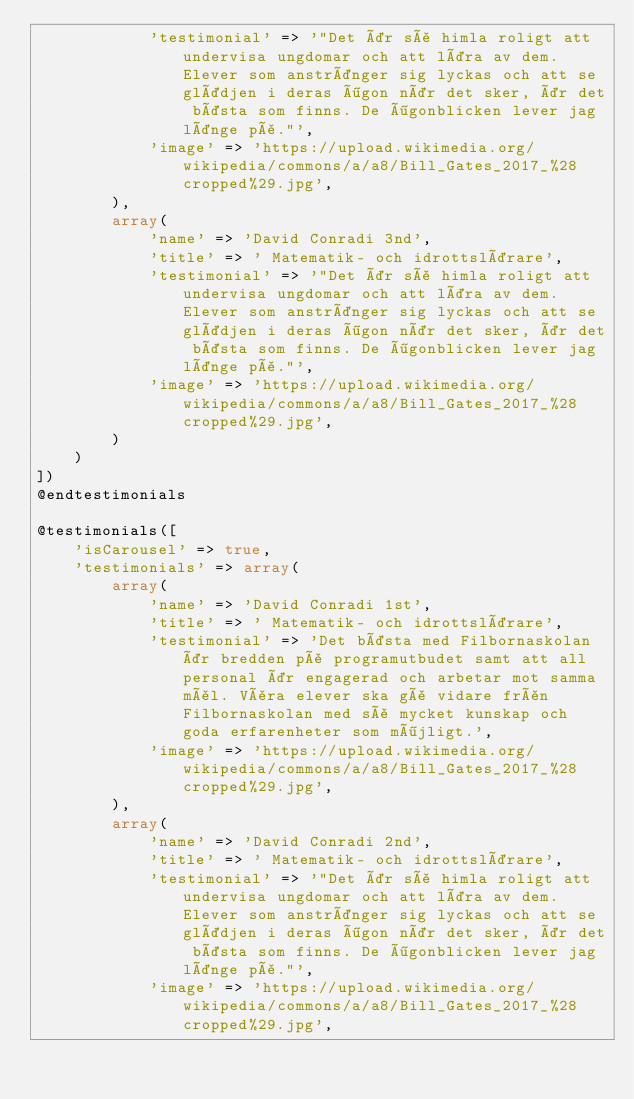Convert code to text. <code><loc_0><loc_0><loc_500><loc_500><_PHP_>            'testimonial' => '"Det är så himla roligt att undervisa ungdomar och att lära av dem. Elever som anstränger sig lyckas och att se glädjen i deras ögon när det sker, är det bästa som finns. De ögonblicken lever jag länge på."',
            'image' => 'https://upload.wikimedia.org/wikipedia/commons/a/a8/Bill_Gates_2017_%28cropped%29.jpg',
        ),
        array(
            'name' => 'David Conradi 3nd',
            'title' => ' Matematik- och idrottslärare',
            'testimonial' => '"Det är så himla roligt att undervisa ungdomar och att lära av dem. Elever som anstränger sig lyckas och att se glädjen i deras ögon när det sker, är det bästa som finns. De ögonblicken lever jag länge på."',
            'image' => 'https://upload.wikimedia.org/wikipedia/commons/a/a8/Bill_Gates_2017_%28cropped%29.jpg',
        )
    )
])
@endtestimonials

@testimonials([
    'isCarousel' => true,
    'testimonials' => array(
        array(
            'name' => 'David Conradi 1st',
            'title' => ' Matematik- och idrottslärare',
            'testimonial' => 'Det bästa med Filbornaskolan är bredden på programutbudet samt att all personal är engagerad och arbetar mot samma mål. Våra elever ska gå vidare från Filbornaskolan med så mycket kunskap och goda erfarenheter som möjligt.',
            'image' => 'https://upload.wikimedia.org/wikipedia/commons/a/a8/Bill_Gates_2017_%28cropped%29.jpg',
        ),
        array(
            'name' => 'David Conradi 2nd',
            'title' => ' Matematik- och idrottslärare',
            'testimonial' => '"Det är så himla roligt att undervisa ungdomar och att lära av dem. Elever som anstränger sig lyckas och att se glädjen i deras ögon när det sker, är det bästa som finns. De ögonblicken lever jag länge på."',
            'image' => 'https://upload.wikimedia.org/wikipedia/commons/a/a8/Bill_Gates_2017_%28cropped%29.jpg',</code> 